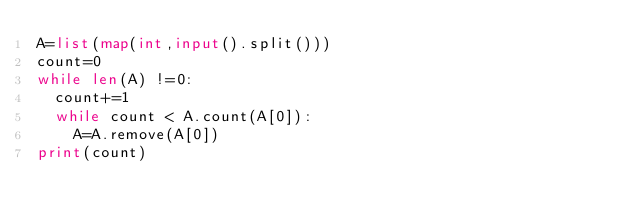<code> <loc_0><loc_0><loc_500><loc_500><_Python_>A=list(map(int,input().split()))
count=0
while len(A) !=0:
  count+=1
  while count < A.count(A[0]):
    A=A.remove(A[0])
print(count)</code> 